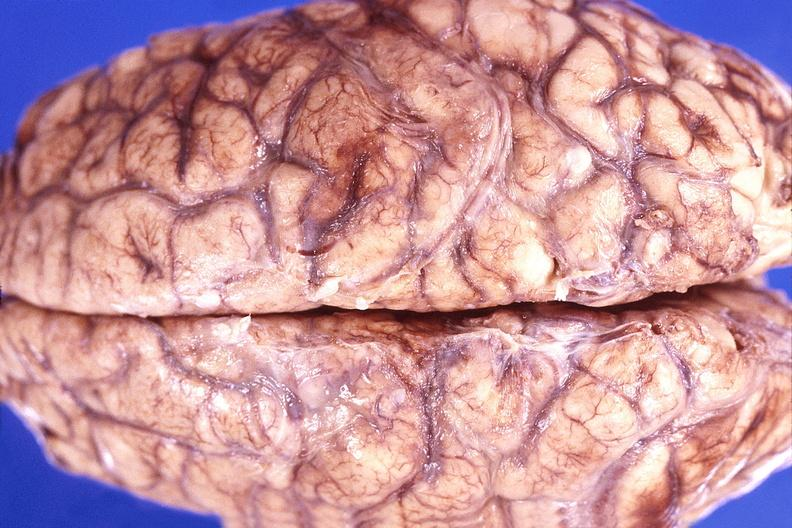s nervous present?
Answer the question using a single word or phrase. Yes 